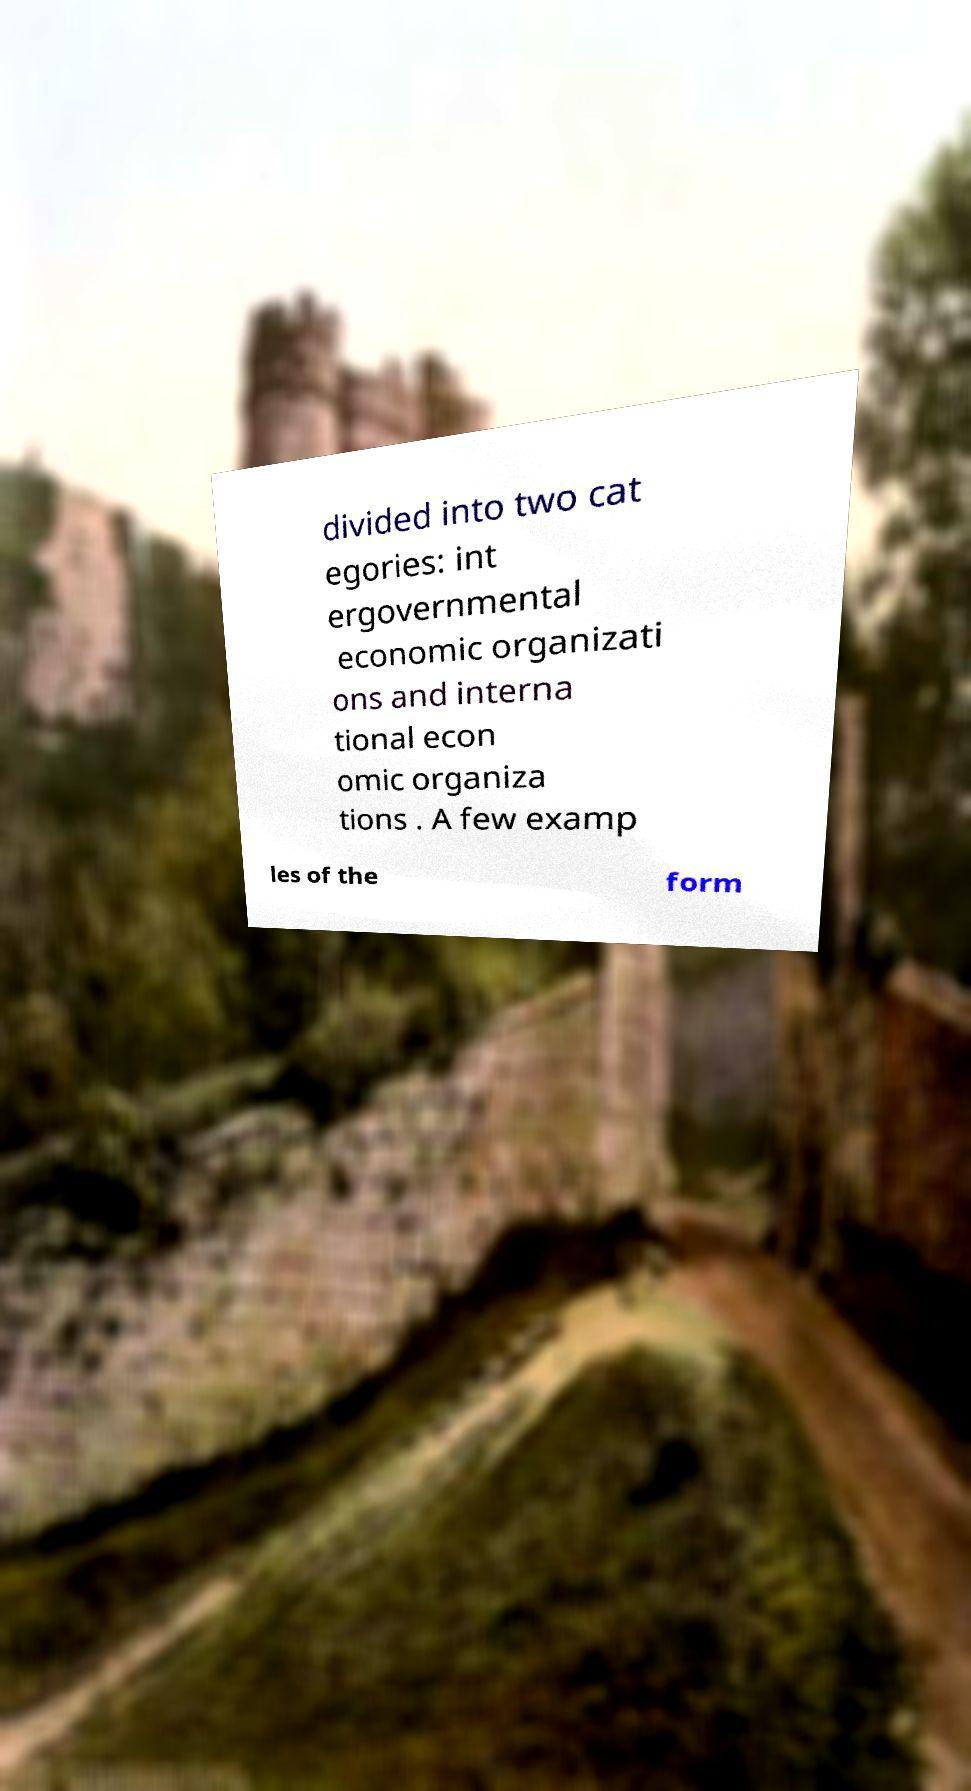For documentation purposes, I need the text within this image transcribed. Could you provide that? divided into two cat egories: int ergovernmental economic organizati ons and interna tional econ omic organiza tions . A few examp les of the form 